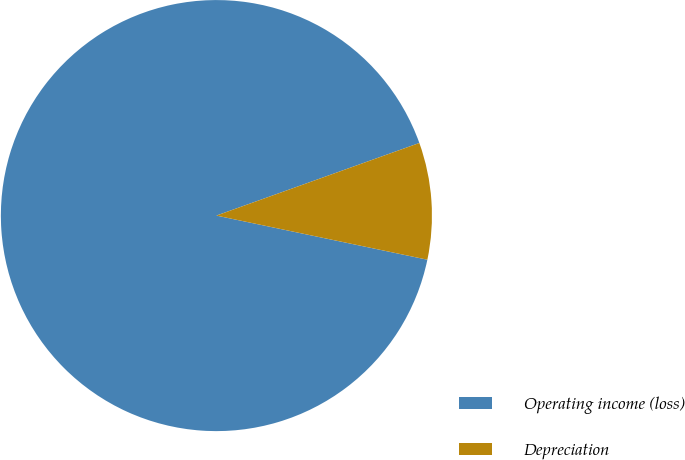<chart> <loc_0><loc_0><loc_500><loc_500><pie_chart><fcel>Operating income (loss)<fcel>Depreciation<nl><fcel>91.25%<fcel>8.75%<nl></chart> 